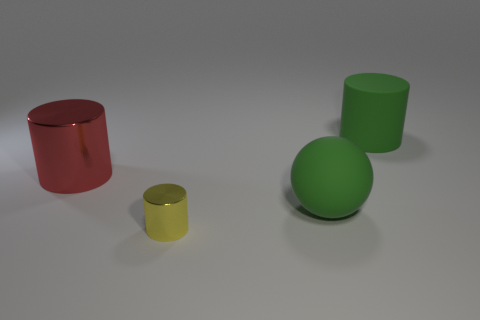How many large things have the same shape as the tiny yellow thing?
Your answer should be compact. 2. The cylinder that is the same material as the small yellow thing is what size?
Your answer should be compact. Large. Do the red shiny thing and the yellow metal cylinder have the same size?
Offer a terse response. No. Are any cyan metallic cylinders visible?
Offer a very short reply. No. There is a object that is the same color as the large sphere; what is its size?
Offer a terse response. Large. How big is the green thing behind the big matte ball that is on the right side of the large cylinder left of the large green matte sphere?
Your answer should be very brief. Large. How many other red cylinders are the same material as the big red cylinder?
Your answer should be very brief. 0. How many rubber spheres are the same size as the green cylinder?
Keep it short and to the point. 1. There is a large cylinder that is on the left side of the green object right of the green matte thing in front of the big green rubber cylinder; what is it made of?
Ensure brevity in your answer.  Metal. What number of objects are large green spheres or cylinders?
Your answer should be very brief. 4. 